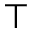<formula> <loc_0><loc_0><loc_500><loc_500>\top</formula> 